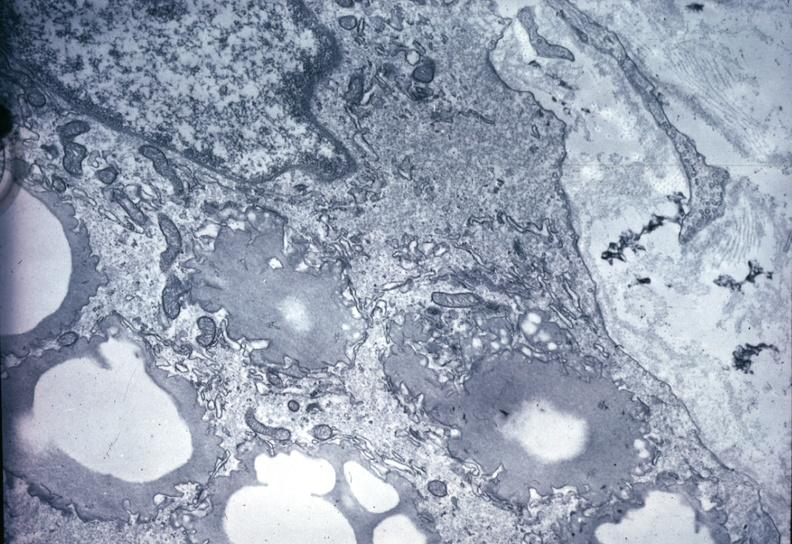s artery present?
Answer the question using a single word or phrase. Yes 